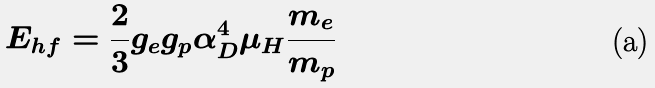<formula> <loc_0><loc_0><loc_500><loc_500>E _ { h f } = \frac { 2 } { 3 } g _ { e } g _ { p } \alpha _ { D } ^ { 4 } \mu _ { H } \frac { m _ { e } } { m _ { p } }</formula> 